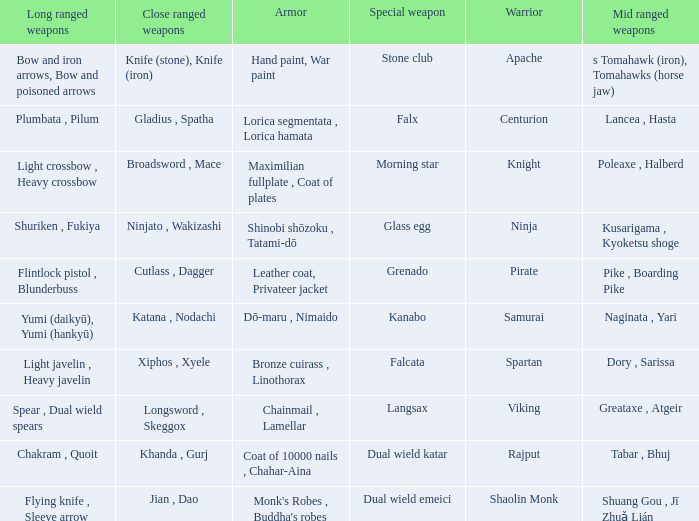If the Close ranged weapons are the knife (stone), knife (iron), what are the Long ranged weapons? Bow and iron arrows, Bow and poisoned arrows. 